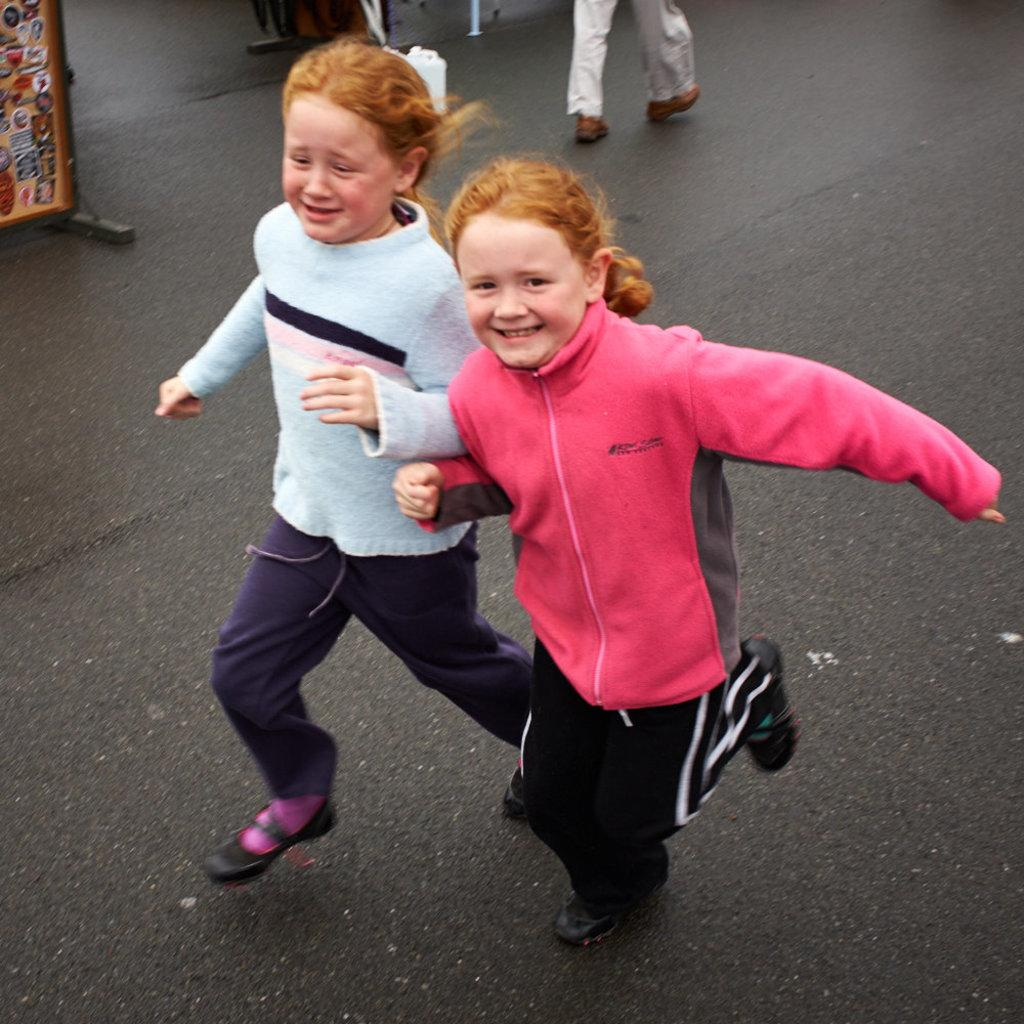What are the kids in the image doing? There are two kids running in the image. What is at the bottom of the image? There is a road at the bottom of the image. What can be seen on the side of the road? There is a hoarding visible in the image. What type of powder is being used by the kids to make the road slippery in the image? There is no indication in the image that the kids are using any powder to make the road slippery. 